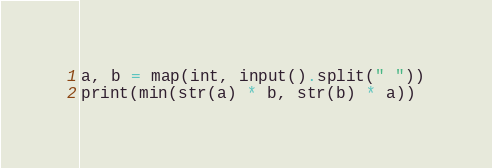<code> <loc_0><loc_0><loc_500><loc_500><_Python_>a, b = map(int, input().split(" "))
print(min(str(a) * b, str(b) * a))</code> 